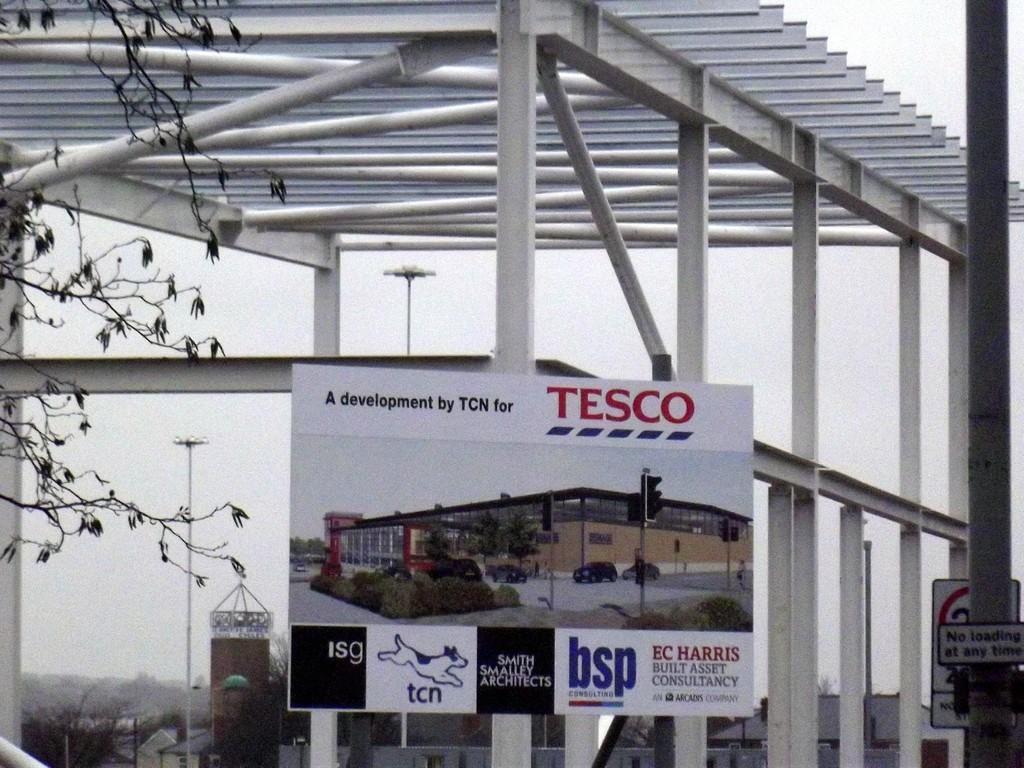How would you summarize this image in a sentence or two? In this picture there is a poster in the center of the image, there is a pole on the right side of the image, there are trees in the bottom left side of the image. 